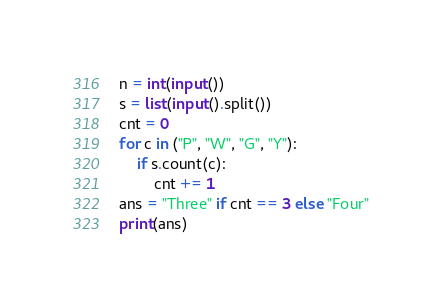<code> <loc_0><loc_0><loc_500><loc_500><_Python_>n = int(input())
s = list(input().split())
cnt = 0
for c in ("P", "W", "G", "Y"):
    if s.count(c):
        cnt += 1
ans = "Three" if cnt == 3 else "Four"
print(ans)
</code> 